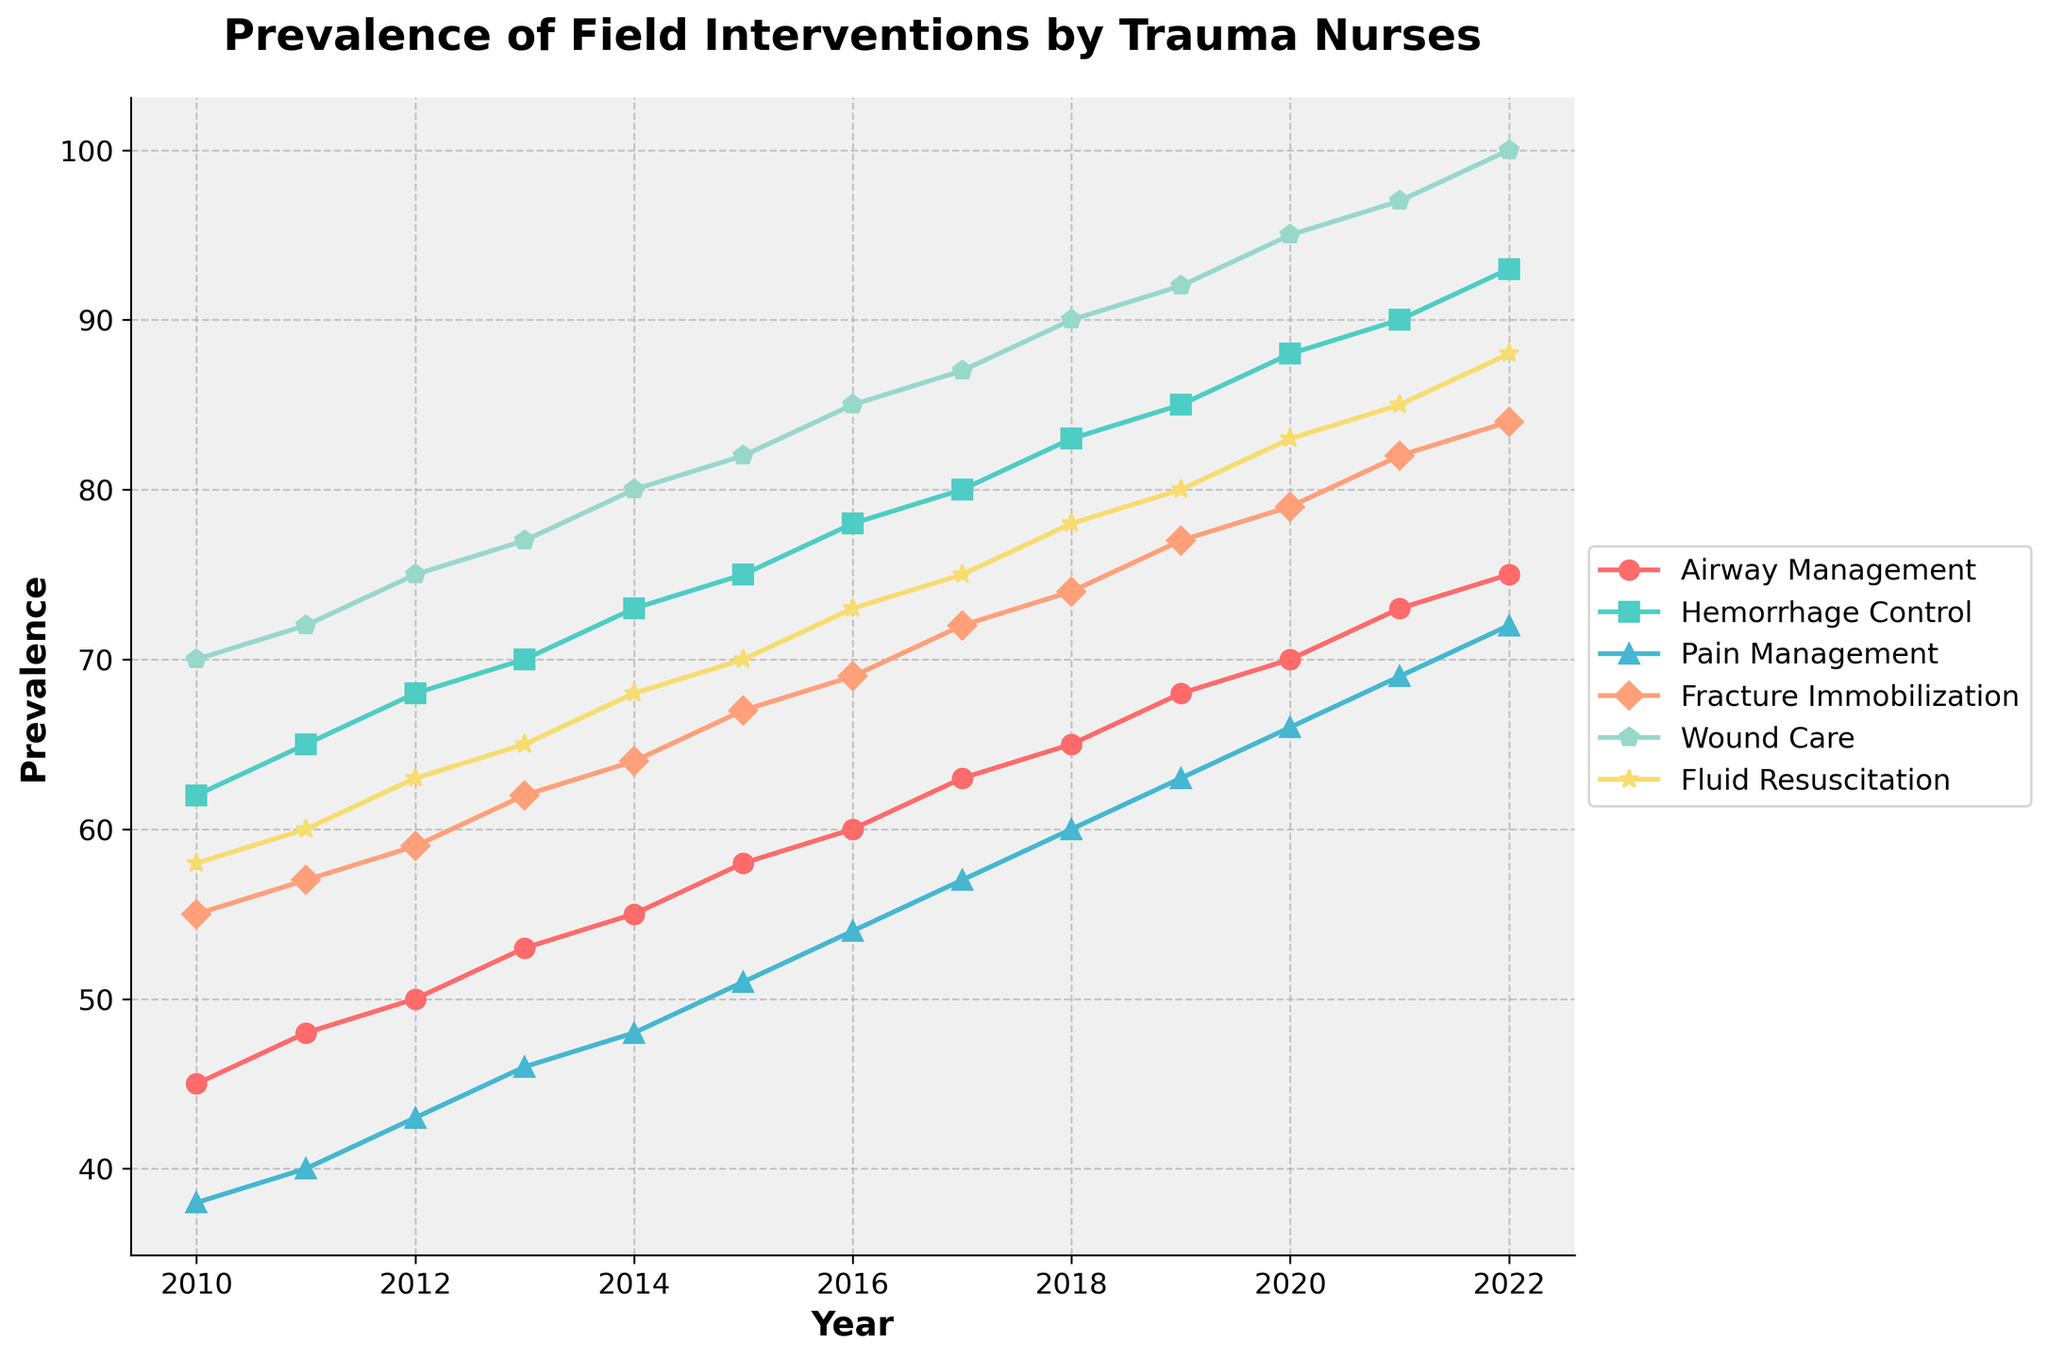What year did pain management first surpass a prevalence of 50? Locate where the "Pain Management" line crosses the 50 mark on the y-axis and identify the corresponding year on the x-axis.
Answer: 2015 In which year was the prevalence of wound care and airway management equal? Find where the lines representing "Wound Care" and "Airway Management" intersect and identify the corresponding year on the x-axis.
Answer: They never intersect Which intervention had the highest increase in prevalence from 2010 to 2022? Determine the difference in prevalence from 2010 to 2022 for each intervention and find the maximum difference.
Answer: Wound Care How much higher was the prevalence of fluid resuscitation compared to fracture immobilization in 2020? Subtract the prevalence of "Fracture Immobilization" from "Fluid Resuscitation" for the year 2020.
Answer: 4 Has hemorrhage control consistently increased each year? Check the "Hemorrhage Control" line for any decreases or constant values from 2010 to 2022.
Answer: Yes What is the average prevalence of airway management from 2010 to 2022? Sum the prevalence values for "Airway Management" from 2010 to 2022 and divide by the number of years (13).
Answer: 61 Which intervention had the smallest increase in prevalence from 2010 to 2011? Calculate the increase for each intervention between 2010 and 2011 and identify the smallest increase.
Answer: Pain Management What are the two years with the highest prevalence difference for wound care? Find the years corresponding to the largest single increase in "Wound Care" by checking the differences year by year.
Answer: 2021-2022 By how many percent did fracture immobilization increase from 2010 to 2022? Calculate the percentage increase from 2010 to 2022 using the formula [(value in 2022 - value in 2010) / value in 2010] * 100.
Answer: 52.73% How does the prevalence of airway management in 2019 compare with that in 2010? Subtract the prevalence of "Airway Management" in 2010 from that in 2019 to find the difference.
Answer: 23 higher 